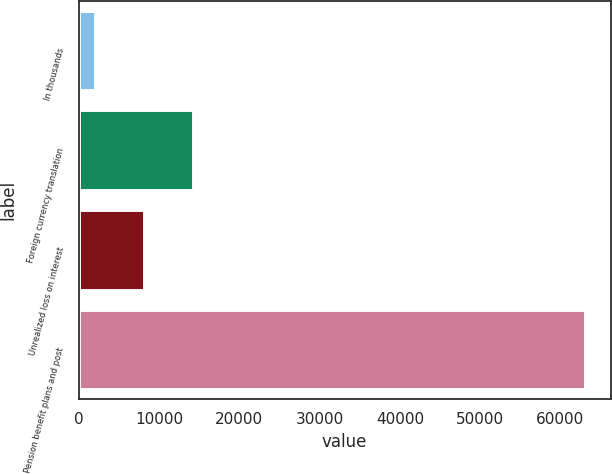<chart> <loc_0><loc_0><loc_500><loc_500><bar_chart><fcel>In thousands<fcel>Foreign currency translation<fcel>Unrealized loss on interest<fcel>Pension benefit plans and post<nl><fcel>2012<fcel>14226.8<fcel>8119.4<fcel>63086<nl></chart> 